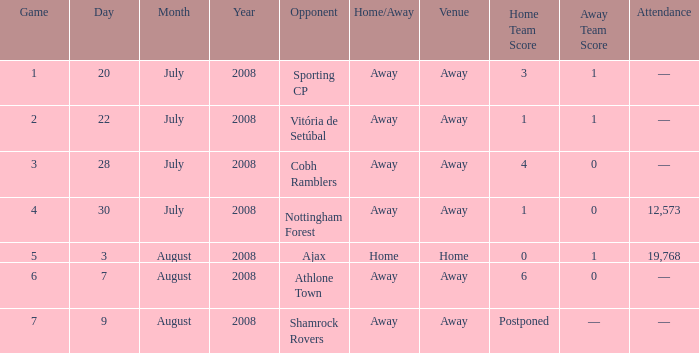What is the result of the game with a game number greater than 6 and an away venue? Postponed. 